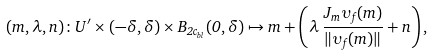Convert formula to latex. <formula><loc_0><loc_0><loc_500><loc_500>( m , \lambda , n ) \colon U ^ { \prime } \times ( - \delta , \delta ) \times B _ { 2 c _ { b l } } ( 0 , \delta ) \mapsto m + \left ( \lambda \, \frac { J _ { m } \upsilon _ { f } ( m ) } { \| \upsilon _ { f } ( m ) \| } + n \right ) ,</formula> 